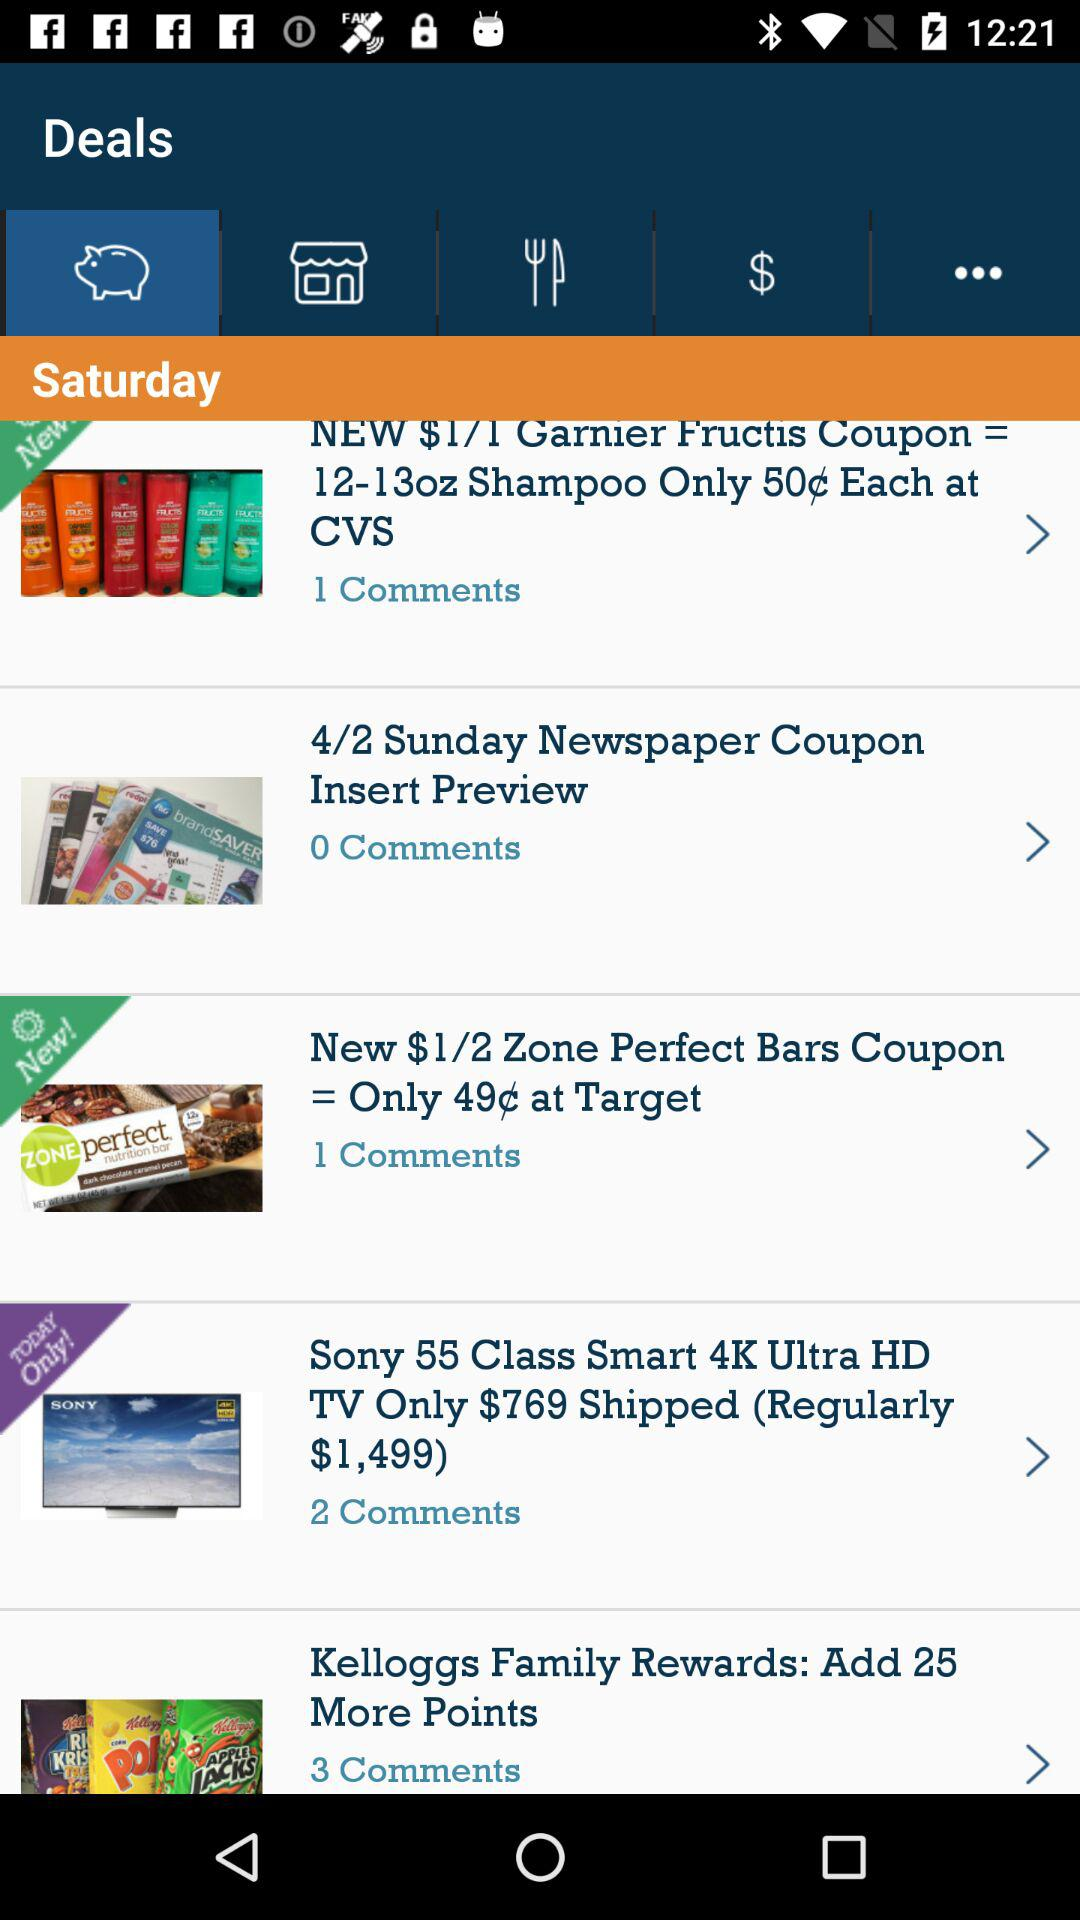How many comments are there for "Kelloggs Family Rewards: Add 25 More Points"? There are 3 comments for "Kelloggs Family Rewards: Add 25 More Points". 